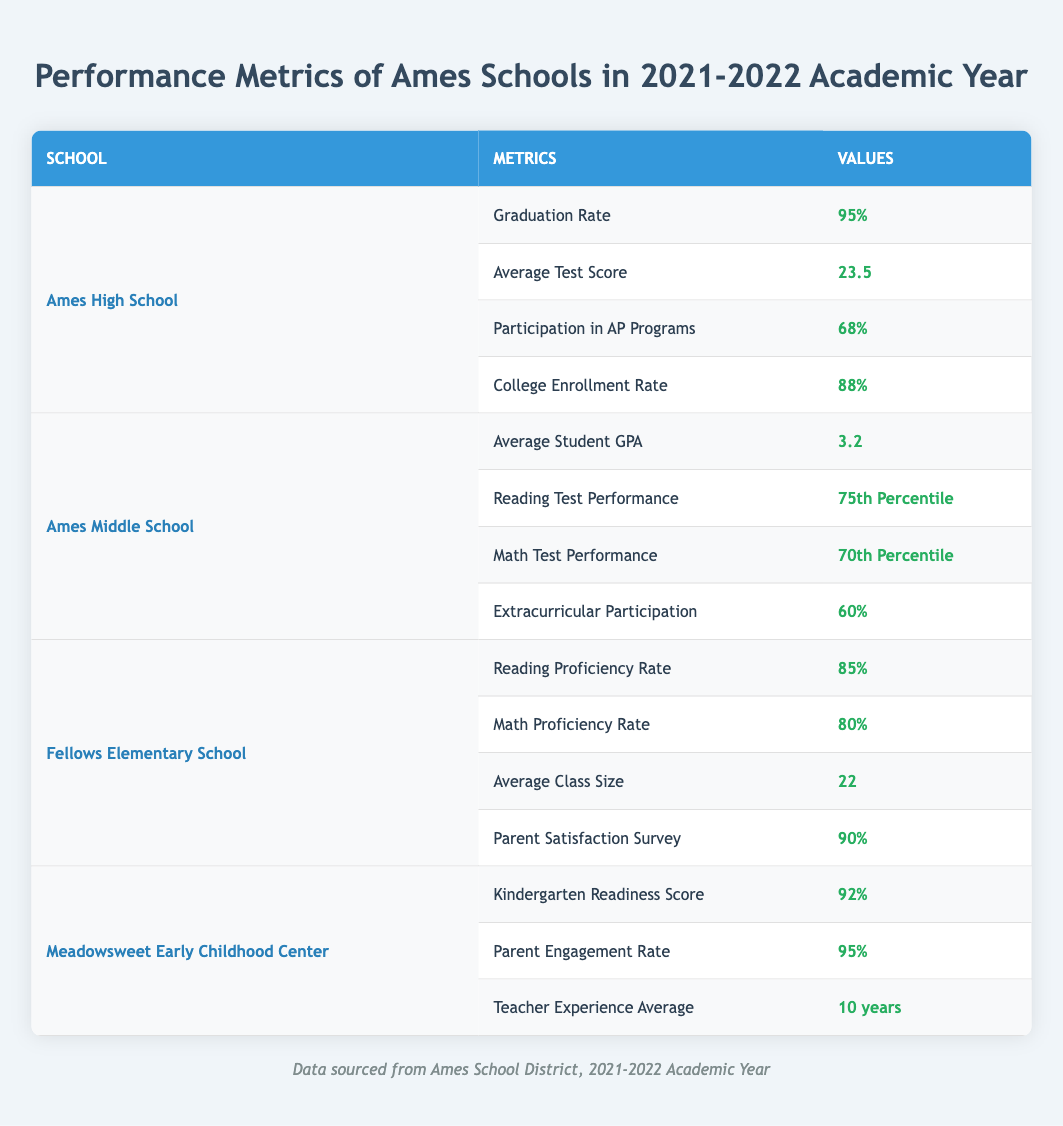What is the graduation rate at Ames High School? The graduation rate for Ames High School is explicitly stated in the table as 95%.
Answer: 95% What is the average test score for Ames High School? The average test score for Ames High School is found in the table and is listed as 23.5.
Answer: 23.5 Which school has the highest parent engagement rate? The parent engagement rate is highest at Meadowsweet Early Childhood Center, where it is reported at 95%.
Answer: Meadowsweet Early Childhood Center What is the average student GPA at Ames Middle School? The average student GPA for Ames Middle School can be located in the metrics and is 3.2.
Answer: 3.2 How many years of teacher experience does Meadowsweet Early Childhood Center report? The table shows that Meadowsweet Early Childhood Center has an average teacher experience of 10 years.
Answer: 10 years Which school has the lowest participation in extracurricular activities? Looking at the data, Ames Middle School has the lowest extracurricular participation at 60%.
Answer: Ames Middle School What is the reading proficiency rate at Fellows Elementary School? The reading proficiency rate is listed for Fellows Elementary School in the table as 85%.
Answer: 85% What percentage of students at Ames High School participate in AP programs? The table states that the participation in AP programs at Ames High School is 68%.
Answer: 68% If we average the college enrollment rate of Ames High School and the parent satisfaction survey of Fellows Elementary School, what would that be? The college enrollment rate is 88% at Ames High School and the parent satisfaction rate is 90% at Fellows Elementary. To average, (88 + 90) / 2 = 89%.
Answer: 89% Is the average class size at Fellows Elementary School above or below 25? The average class size at Fellows Elementary School is stated as 22, which is below 25.
Answer: Below How does the math standardized test performance of Ames Middle School compare to the reading performance? Ames Middle School's standardized test performance in Math is at the 70th percentile, while Reading is at the 75th percentile, indicating Reading performance is better.
Answer: Reading performance is better 